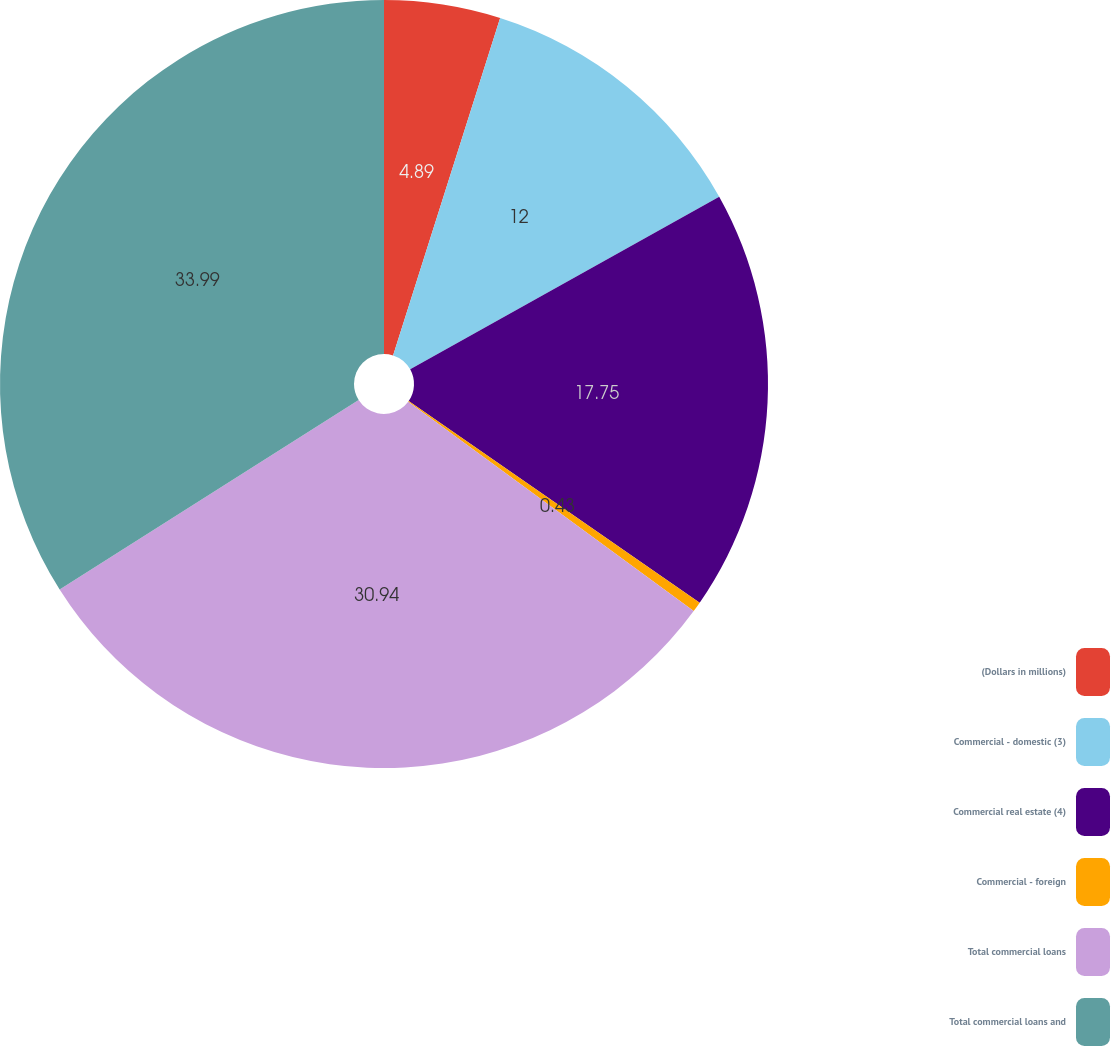Convert chart to OTSL. <chart><loc_0><loc_0><loc_500><loc_500><pie_chart><fcel>(Dollars in millions)<fcel>Commercial - domestic (3)<fcel>Commercial real estate (4)<fcel>Commercial - foreign<fcel>Total commercial loans<fcel>Total commercial loans and<nl><fcel>4.89%<fcel>12.0%<fcel>17.75%<fcel>0.43%<fcel>30.94%<fcel>33.99%<nl></chart> 